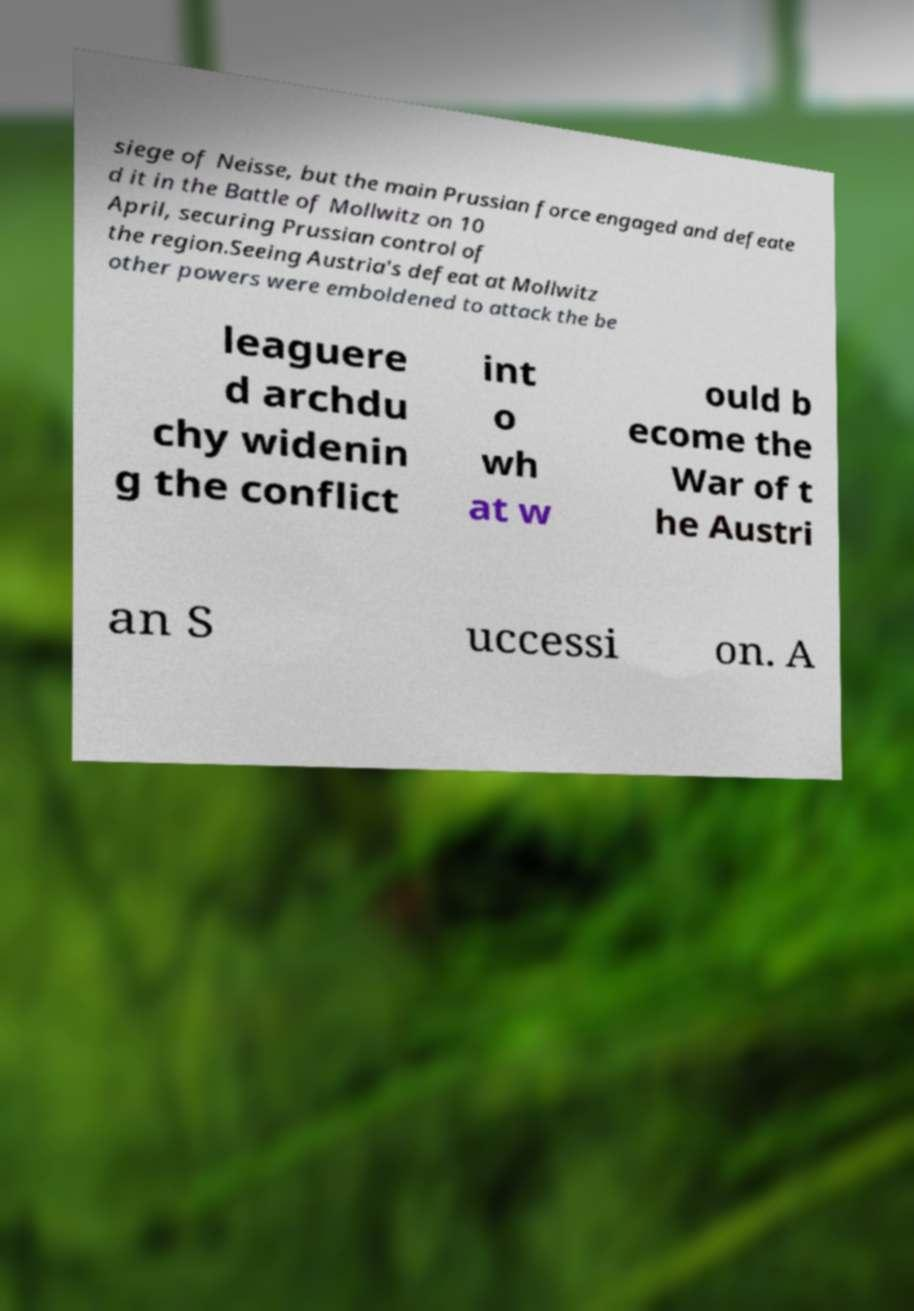For documentation purposes, I need the text within this image transcribed. Could you provide that? siege of Neisse, but the main Prussian force engaged and defeate d it in the Battle of Mollwitz on 10 April, securing Prussian control of the region.Seeing Austria's defeat at Mollwitz other powers were emboldened to attack the be leaguere d archdu chy widenin g the conflict int o wh at w ould b ecome the War of t he Austri an S uccessi on. A 